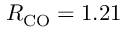<formula> <loc_0><loc_0><loc_500><loc_500>R _ { C O } = 1 . 2 1</formula> 